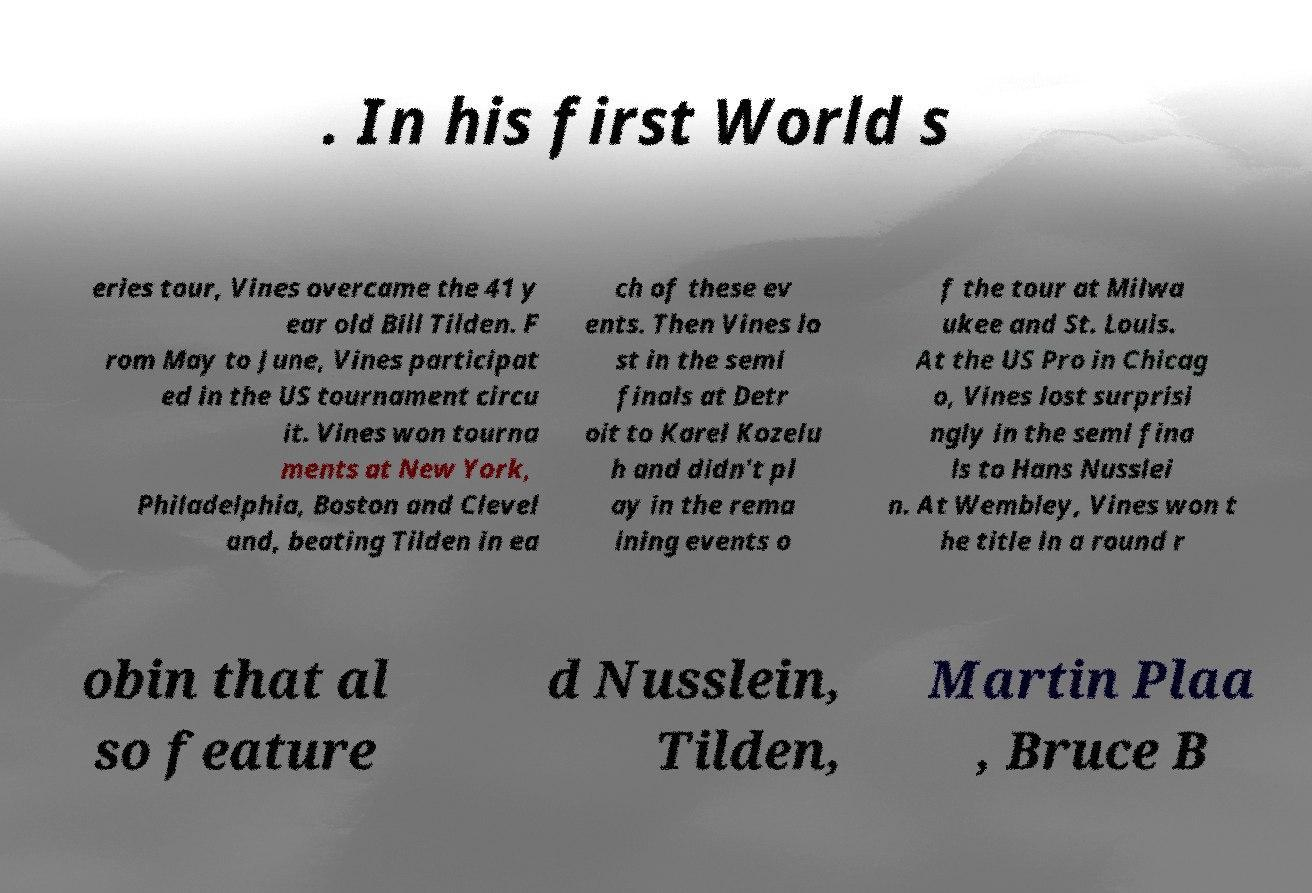Can you accurately transcribe the text from the provided image for me? . In his first World s eries tour, Vines overcame the 41 y ear old Bill Tilden. F rom May to June, Vines participat ed in the US tournament circu it. Vines won tourna ments at New York, Philadelphia, Boston and Clevel and, beating Tilden in ea ch of these ev ents. Then Vines lo st in the semi finals at Detr oit to Karel Kozelu h and didn't pl ay in the rema ining events o f the tour at Milwa ukee and St. Louis. At the US Pro in Chicag o, Vines lost surprisi ngly in the semi fina ls to Hans Nusslei n. At Wembley, Vines won t he title in a round r obin that al so feature d Nusslein, Tilden, Martin Plaa , Bruce B 